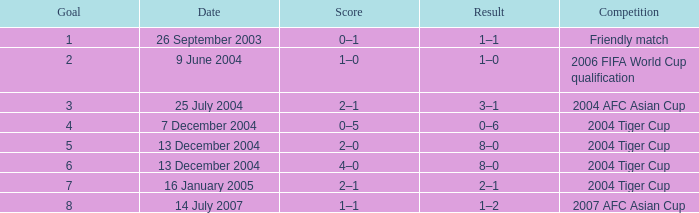Which date has 3 as the aim? 25 July 2004. 